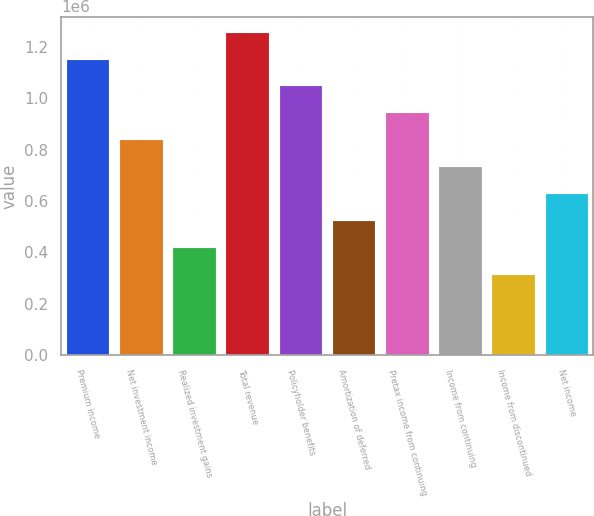Convert chart. <chart><loc_0><loc_0><loc_500><loc_500><bar_chart><fcel>Premium income<fcel>Net investment income<fcel>Realized investment gains<fcel>Total revenue<fcel>Policyholder benefits<fcel>Amortization of deferred<fcel>Pretax income from continuing<fcel>Income from continuing<fcel>Income from discontinued<fcel>Net income<nl><fcel>1.15062e+06<fcel>836812<fcel>418407<fcel>1.25522e+06<fcel>1.04601e+06<fcel>523008<fcel>941414<fcel>732211<fcel>313805<fcel>627610<nl></chart> 